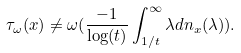Convert formula to latex. <formula><loc_0><loc_0><loc_500><loc_500>\tau _ { \omega } ( x ) \neq \omega ( \frac { - 1 } { \log ( t ) } \int _ { 1 / t } ^ { \infty } \lambda d n _ { x } ( \lambda ) ) .</formula> 